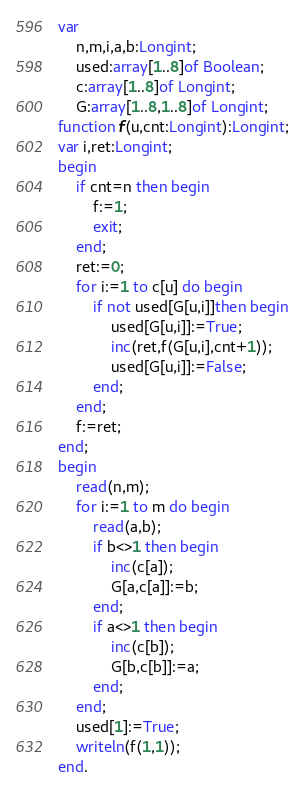<code> <loc_0><loc_0><loc_500><loc_500><_Pascal_>var
	n,m,i,a,b:Longint;
	used:array[1..8]of Boolean;
	c:array[1..8]of Longint;
	G:array[1..8,1..8]of Longint;
function f(u,cnt:Longint):Longint;
var i,ret:Longint;
begin
	if cnt=n then begin
		f:=1;
		exit;
	end;
	ret:=0;
	for i:=1 to c[u] do begin
		if not used[G[u,i]]then begin
			used[G[u,i]]:=True;
			inc(ret,f(G[u,i],cnt+1));
			used[G[u,i]]:=False;
		end;
	end;
	f:=ret;
end;
begin
	read(n,m);
	for i:=1 to m do begin
		read(a,b);
		if b<>1 then begin
			inc(c[a]);
			G[a,c[a]]:=b;
		end;
		if a<>1 then begin
			inc(c[b]);
			G[b,c[b]]:=a;
		end;
	end;
	used[1]:=True;
	writeln(f(1,1));
end.</code> 